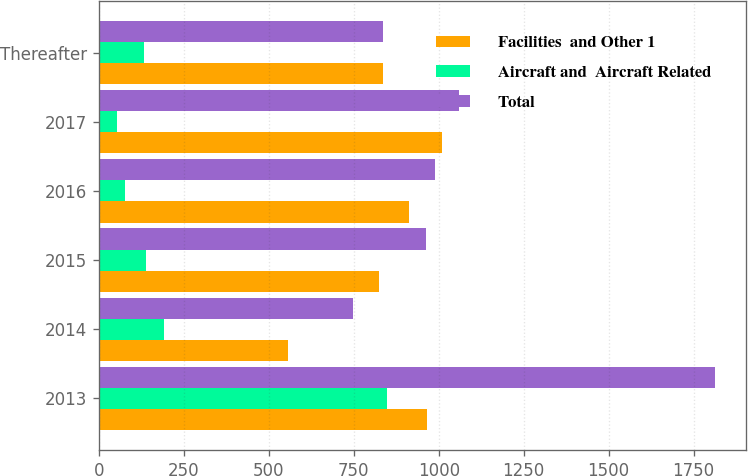Convert chart. <chart><loc_0><loc_0><loc_500><loc_500><stacked_bar_chart><ecel><fcel>2013<fcel>2014<fcel>2015<fcel>2016<fcel>2017<fcel>Thereafter<nl><fcel>Facilities  and Other 1<fcel>965<fcel>558<fcel>824<fcel>912<fcel>1009<fcel>836.5<nl><fcel>Aircraft and  Aircraft Related<fcel>849<fcel>191<fcel>139<fcel>78<fcel>52<fcel>134<nl><fcel>Total<fcel>1814<fcel>749<fcel>963<fcel>990<fcel>1061<fcel>836.5<nl></chart> 